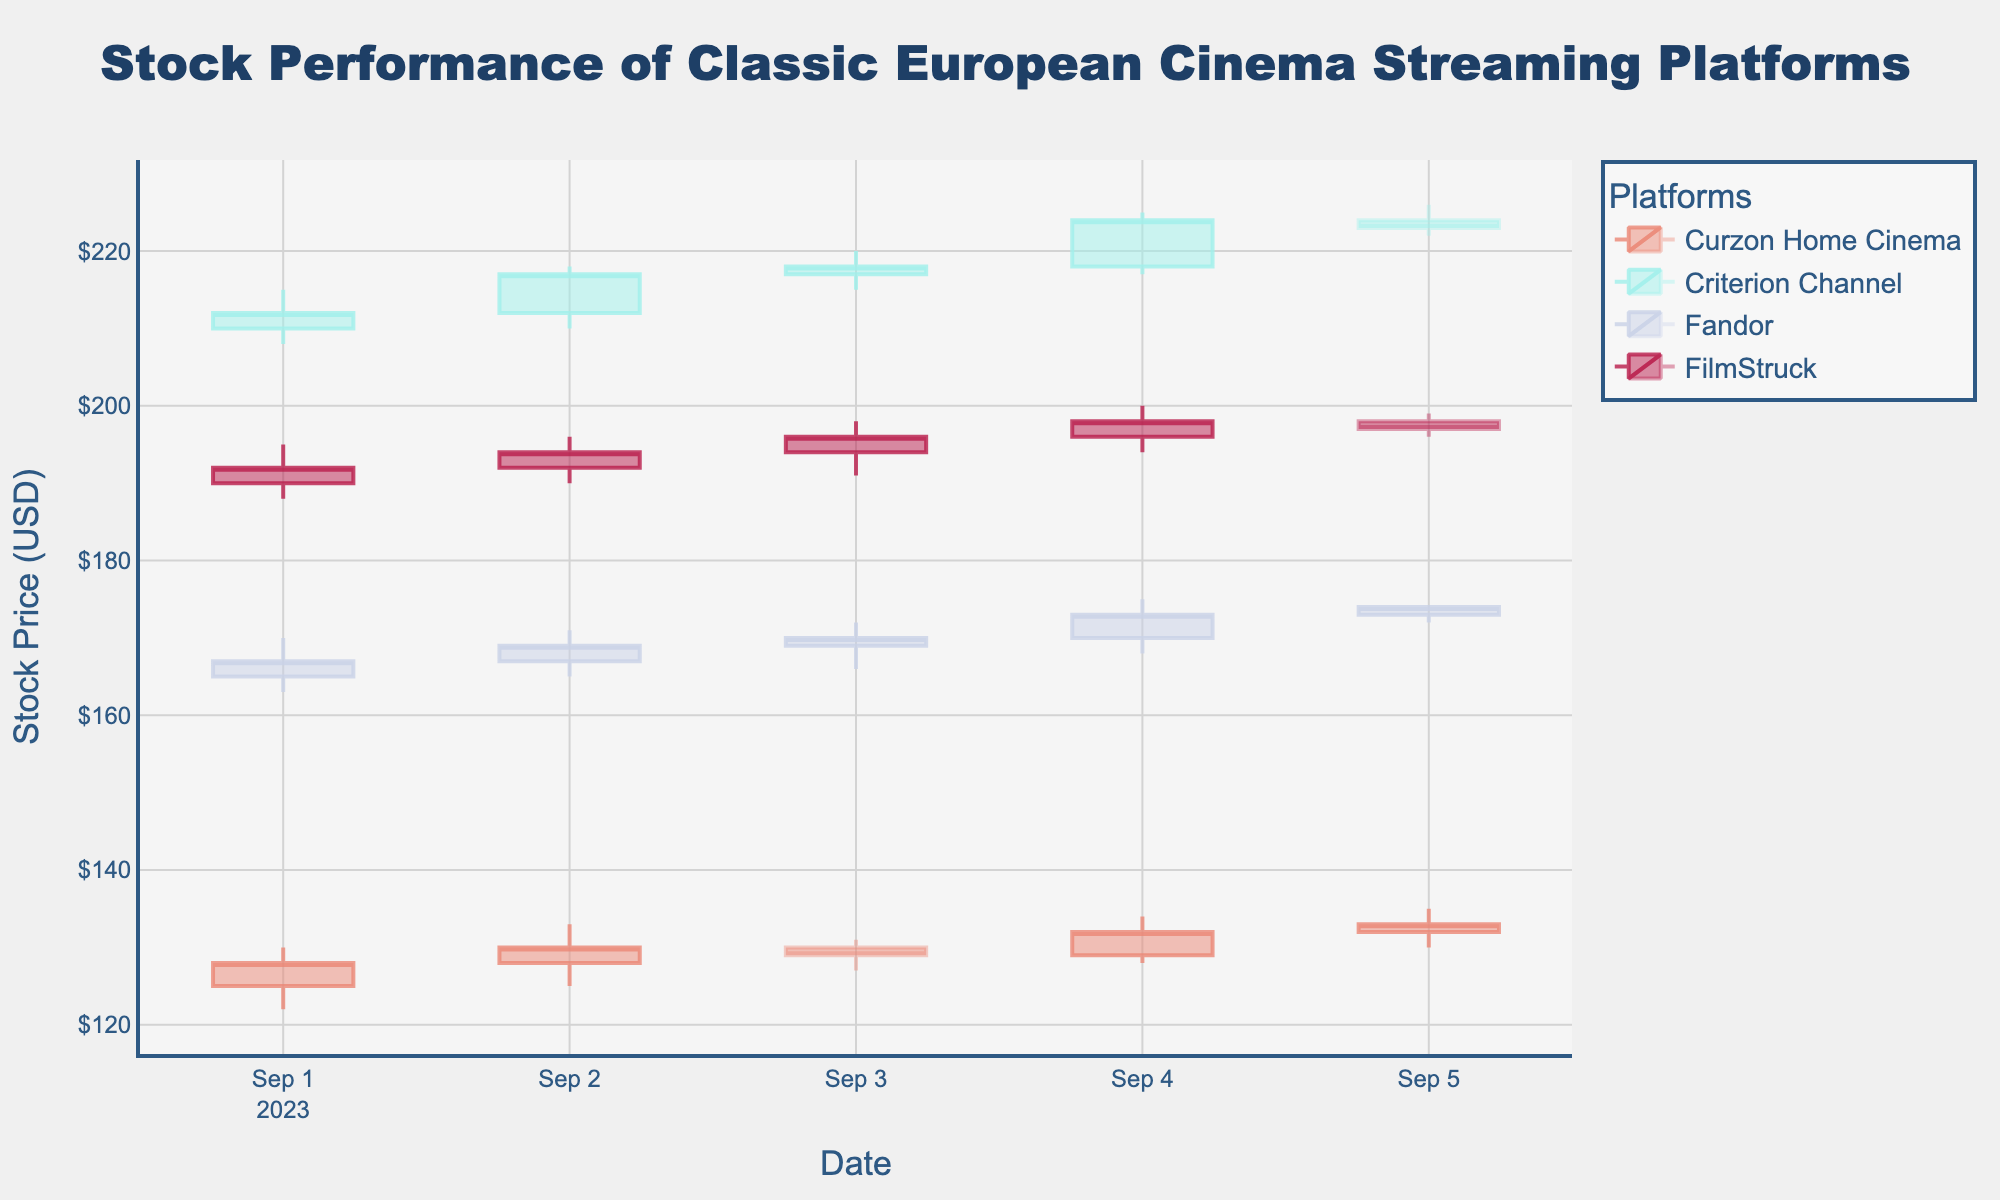What's the title of the plot? The title is typically located at a prominent position at the top of the chart. It is written in larger and bolder text than the rest of the annotations.
Answer: Stock Performance of Classic European Cinema Streaming Platforms Which platform had the highest closing price on September 5th? Look at the candlestick associated with September 5th for each platform and observe the close value (end of the body). Criterion Channel's closing price is the highest among all the platforms.
Answer: Criterion Channel What is the overall trend for Curzon Home Cinema from September 1st to September 5th? Observe the beginning and end of the candlestick series for Curzon Home Cinema, focusing on the closing prices from September 1st to September 5th. The overall trend shows an upward movement.
Answer: Upward Between FilmStruck and Fandor, which platform showed a more consistent increase in their stock price from September 1st to September 5th? Compare the closing prices of FilmStruck and Fandor for each day from September 1st to September 5th. FilmStruck closes higher each day until a slight drop on September 5th, while Fandor shows a steady increase.
Answer: Fandor What day had the highest single-day trading volume and which platform was it associated with? Look for the highest volume number in the dataset and match it to both the date and platform. FilmStruck on September 5th had the highest trading volume.
Answer: September 5th, FilmStruck What was the difference in the closing prices between Criterion Channel and FilmStruck on September 4th? Identify the closing prices for both platforms on September 4th and find the difference. Criterion Channel closed at 224.00 and FilmStruck closed at 198.00.
Answer: $26.00 Which platform had the highest growth in closing price from September 1st to September 4th? Calculate the difference in closing prices from September 1st to September 4th for each platform. Criterion Channel had the highest increase: 224.00 - 212.00 = 12.00
Answer: Criterion Channel Which platform showed a declining trend in stock price and on which days? Look for platforms where the closing price decreases over consecutive days by analyzing the candlesticks for each day. For instance, Curzon Home Cinema showed a slight drop from September 3rd to September 4th.
Answer: Curzon Home Cinema, September 3rd to 4th What is the average closing price of Fandor from September 1st to September 5th? Sum the closing prices of Fandor for each day and divide by the number of days. Calculation: (167 + 169 + 170 + 173 + 174) / 5 = 170.6
Answer: $170.60 How do the trading volumes of Curzon Home Cinema on September 1st and 5th compare? Examine the stated volume figures for September 1st (150,000) and September 5th (155,000) for Curzon Home Cinema. Compare these two values.
Answer: September 5th is higher by 5,000 